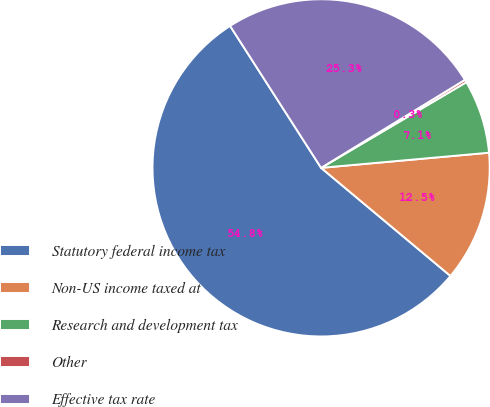Convert chart to OTSL. <chart><loc_0><loc_0><loc_500><loc_500><pie_chart><fcel>Statutory federal income tax<fcel>Non-US income taxed at<fcel>Research and development tax<fcel>Other<fcel>Effective tax rate<nl><fcel>54.84%<fcel>12.51%<fcel>7.05%<fcel>0.26%<fcel>25.33%<nl></chart> 